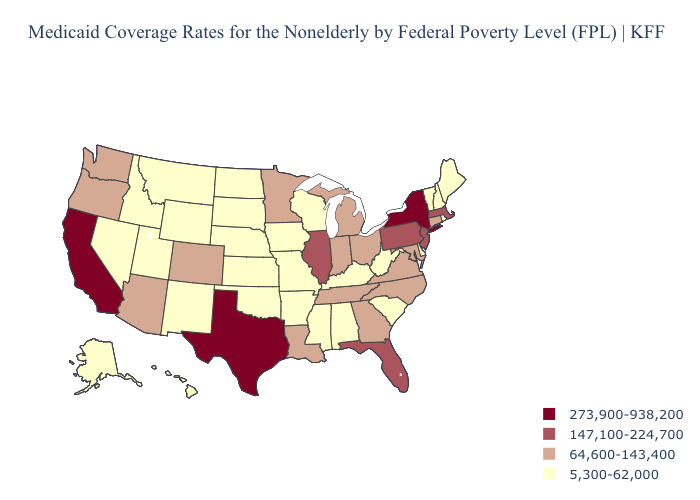Which states have the lowest value in the Northeast?
Quick response, please. Maine, New Hampshire, Rhode Island, Vermont. Name the states that have a value in the range 64,600-143,400?
Short answer required. Arizona, Colorado, Connecticut, Georgia, Indiana, Louisiana, Maryland, Michigan, Minnesota, North Carolina, Ohio, Oregon, Tennessee, Virginia, Washington. What is the lowest value in the South?
Answer briefly. 5,300-62,000. Does Illinois have the same value as Pennsylvania?
Concise answer only. Yes. Name the states that have a value in the range 147,100-224,700?
Keep it brief. Florida, Illinois, Massachusetts, New Jersey, Pennsylvania. What is the value of Massachusetts?
Quick response, please. 147,100-224,700. Does the map have missing data?
Quick response, please. No. What is the highest value in states that border Alabama?
Be succinct. 147,100-224,700. Among the states that border Indiana , does Kentucky have the lowest value?
Write a very short answer. Yes. What is the value of Alabama?
Give a very brief answer. 5,300-62,000. What is the value of Arkansas?
Answer briefly. 5,300-62,000. How many symbols are there in the legend?
Concise answer only. 4. How many symbols are there in the legend?
Concise answer only. 4. What is the value of North Dakota?
Concise answer only. 5,300-62,000. 